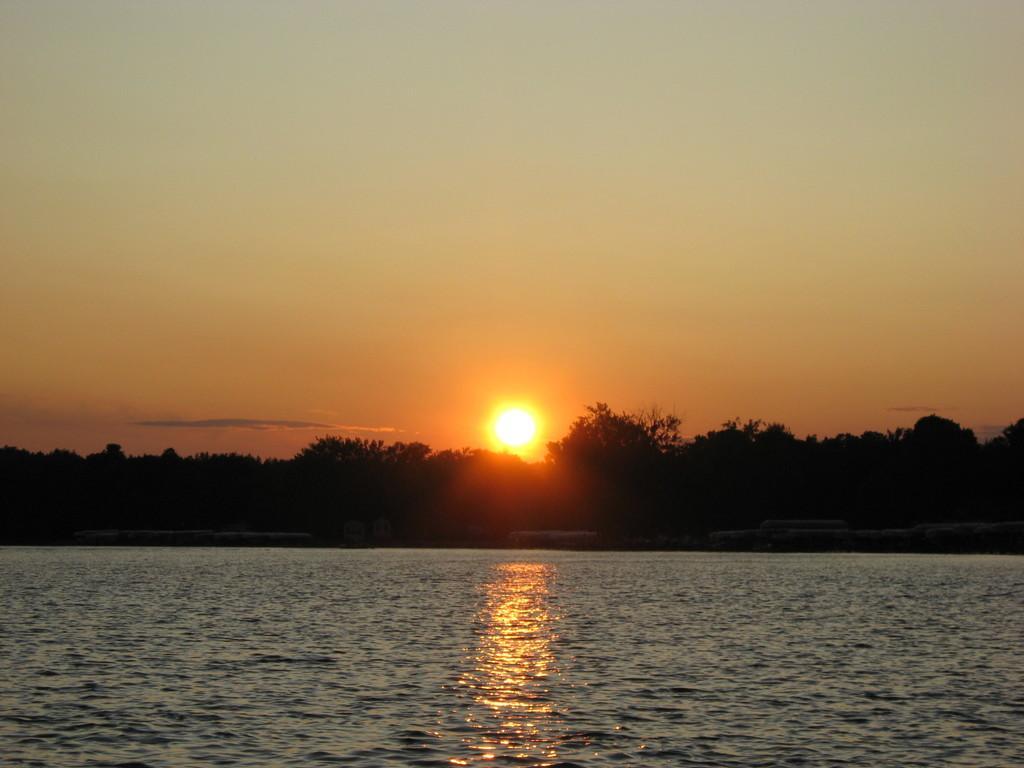Please provide a concise description of this image. In the image there is a lake in the front and behind there are trees and sun setting down in the sky. 